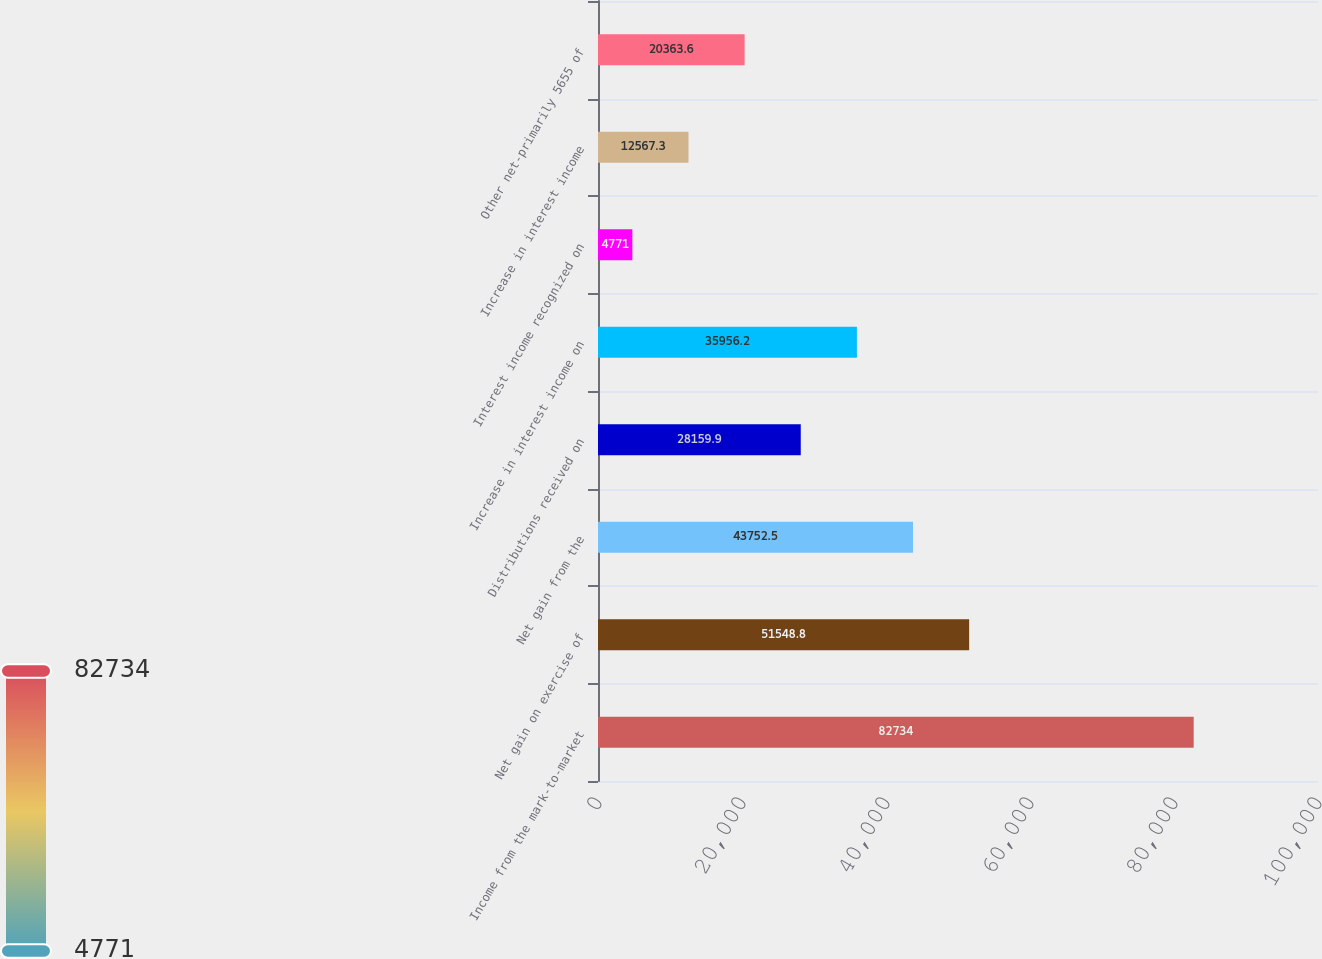Convert chart to OTSL. <chart><loc_0><loc_0><loc_500><loc_500><bar_chart><fcel>Income from the mark-to-market<fcel>Net gain on exercise of<fcel>Net gain from the<fcel>Distributions received on<fcel>Increase in interest income on<fcel>Interest income recognized on<fcel>Increase in interest income<fcel>Other net-primarily 5655 of<nl><fcel>82734<fcel>51548.8<fcel>43752.5<fcel>28159.9<fcel>35956.2<fcel>4771<fcel>12567.3<fcel>20363.6<nl></chart> 